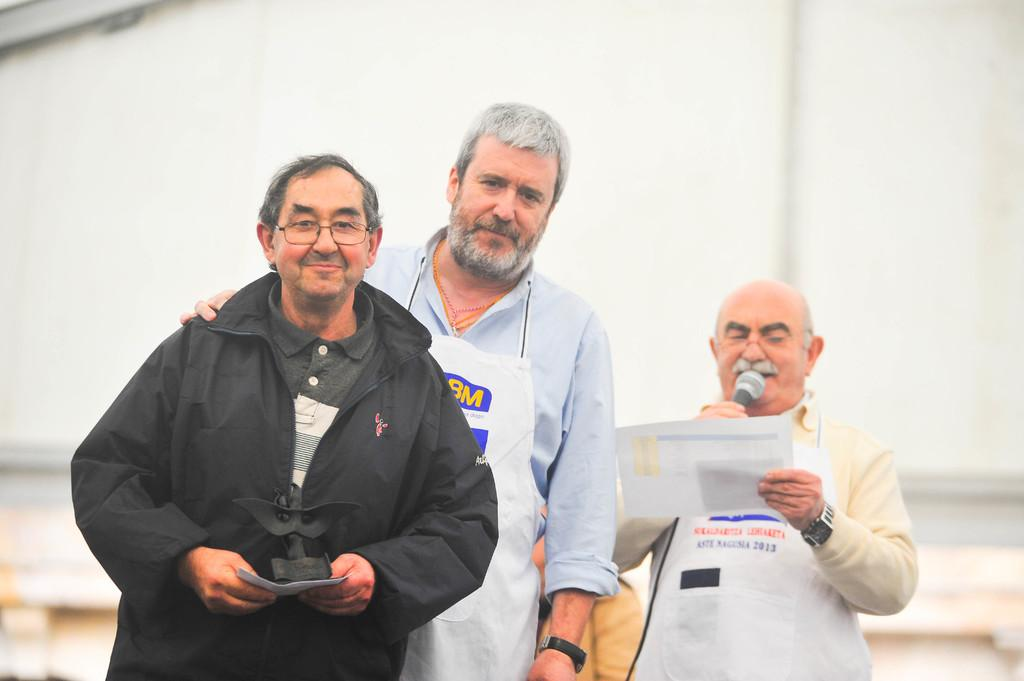How many people are in the image? There are three men standing in the image. What is one of the men holding? One of the men is holding a microphone and a paper. What can be seen in the background of the image? There is a wall visible in the background of the image. How much does the ticket cost in the image? There is no ticket present in the image. What type of care is being provided to the men in the image? There is no indication of care being provided to the men in the image. 